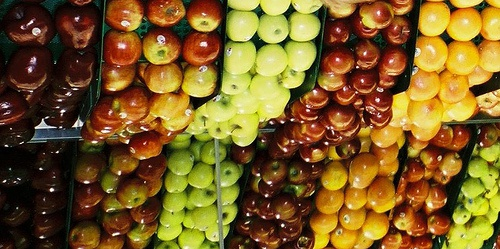Describe the objects in this image and their specific colors. I can see apple in black, brown, and maroon tones, apple in black, khaki, and olive tones, apple in black, maroon, and brown tones, apple in black, maroon, and brown tones, and orange in black, khaki, orange, and gold tones in this image. 